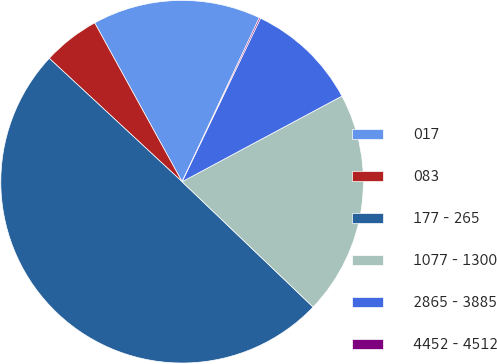Convert chart to OTSL. <chart><loc_0><loc_0><loc_500><loc_500><pie_chart><fcel>017<fcel>083<fcel>177 - 265<fcel>1077 - 1300<fcel>2865 - 3885<fcel>4452 - 4512<nl><fcel>15.01%<fcel>5.08%<fcel>49.77%<fcel>19.98%<fcel>10.05%<fcel>0.12%<nl></chart> 